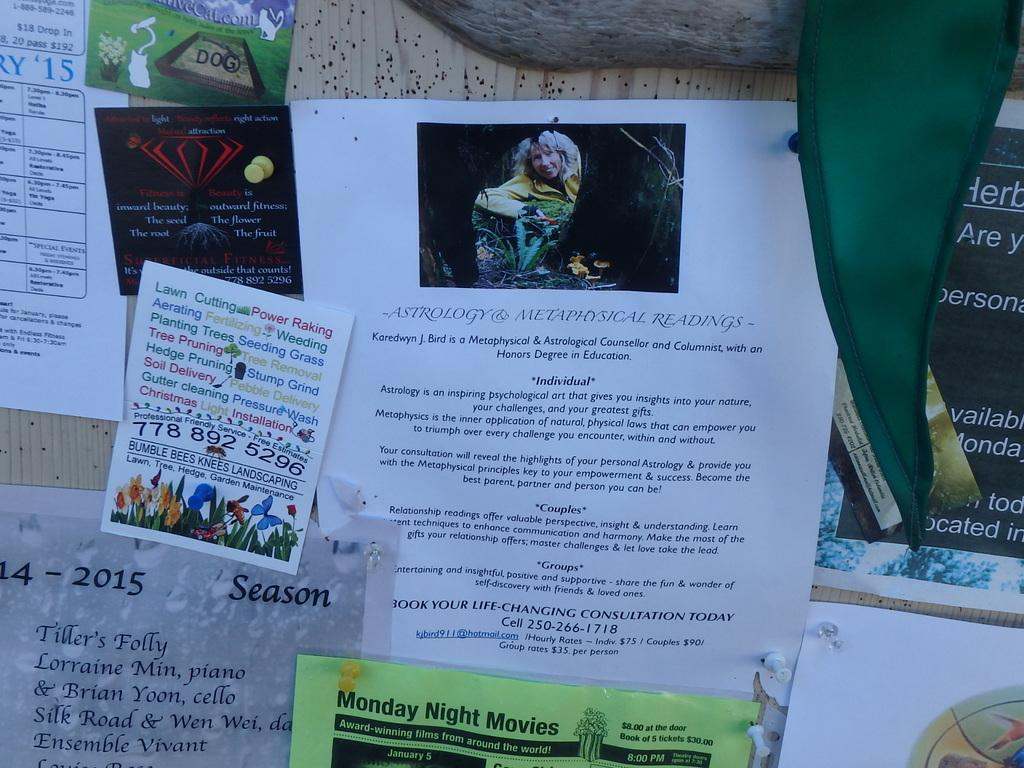<image>
Create a compact narrative representing the image presented. A bulletin board is showing papers pinned on, including Monday Night Movies and ASTROLOGY & METAPHYSICAL READINGS. 